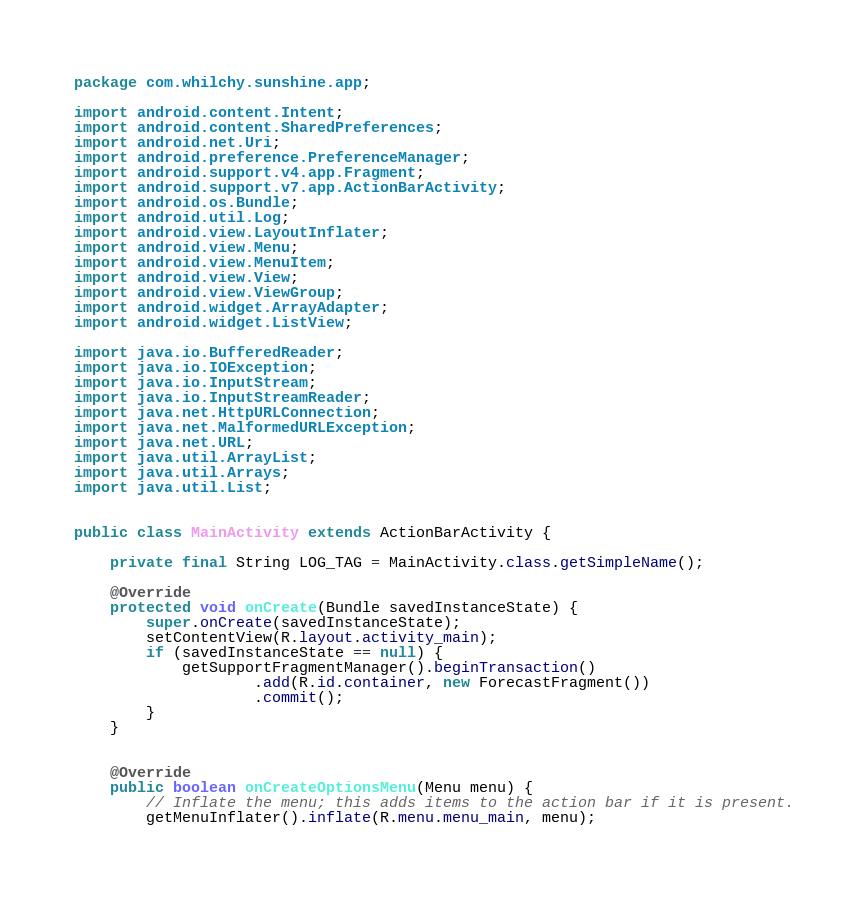<code> <loc_0><loc_0><loc_500><loc_500><_Java_>package com.whilchy.sunshine.app;

import android.content.Intent;
import android.content.SharedPreferences;
import android.net.Uri;
import android.preference.PreferenceManager;
import android.support.v4.app.Fragment;
import android.support.v7.app.ActionBarActivity;
import android.os.Bundle;
import android.util.Log;
import android.view.LayoutInflater;
import android.view.Menu;
import android.view.MenuItem;
import android.view.View;
import android.view.ViewGroup;
import android.widget.ArrayAdapter;
import android.widget.ListView;

import java.io.BufferedReader;
import java.io.IOException;
import java.io.InputStream;
import java.io.InputStreamReader;
import java.net.HttpURLConnection;
import java.net.MalformedURLException;
import java.net.URL;
import java.util.ArrayList;
import java.util.Arrays;
import java.util.List;


public class MainActivity extends ActionBarActivity {

    private final String LOG_TAG = MainActivity.class.getSimpleName();

    @Override
    protected void onCreate(Bundle savedInstanceState) {
        super.onCreate(savedInstanceState);
        setContentView(R.layout.activity_main);
        if (savedInstanceState == null) {
            getSupportFragmentManager().beginTransaction()
                    .add(R.id.container, new ForecastFragment())
                    .commit();
        }
    }


    @Override
    public boolean onCreateOptionsMenu(Menu menu) {
        // Inflate the menu; this adds items to the action bar if it is present.
        getMenuInflater().inflate(R.menu.menu_main, menu);</code> 